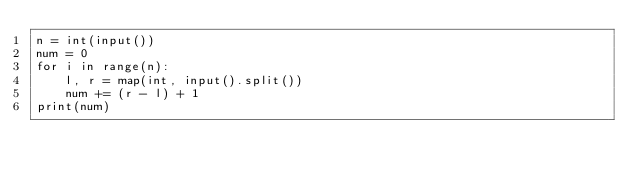Convert code to text. <code><loc_0><loc_0><loc_500><loc_500><_Python_>n = int(input())
num = 0
for i in range(n):
    l, r = map(int, input().split())
    num += (r - l) + 1
print(num)</code> 